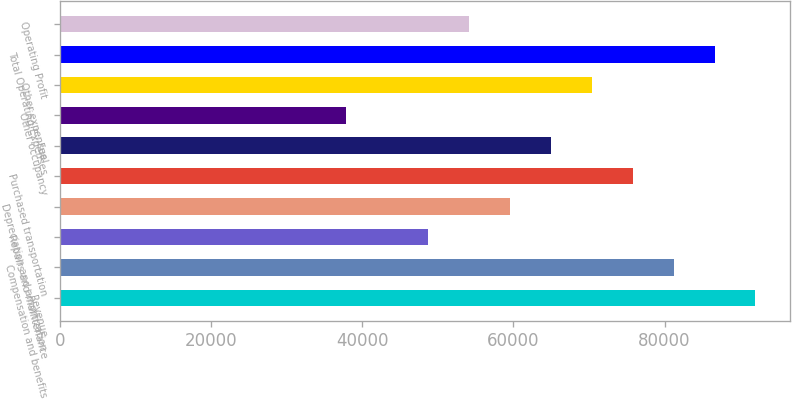<chart> <loc_0><loc_0><loc_500><loc_500><bar_chart><fcel>Revenue<fcel>Compensation and benefits<fcel>Repairs and maintenance<fcel>Depreciation and amortization<fcel>Purchased transportation<fcel>Fuel<fcel>Other occupancy<fcel>Other expenses<fcel>Total Operating Expenses<fcel>Operating Profit<nl><fcel>92015.4<fcel>81190.1<fcel>48714.4<fcel>59539.7<fcel>75777.5<fcel>64952.3<fcel>37889.2<fcel>70364.9<fcel>86602.8<fcel>54127<nl></chart> 